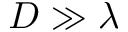<formula> <loc_0><loc_0><loc_500><loc_500>D \gg \lambda</formula> 